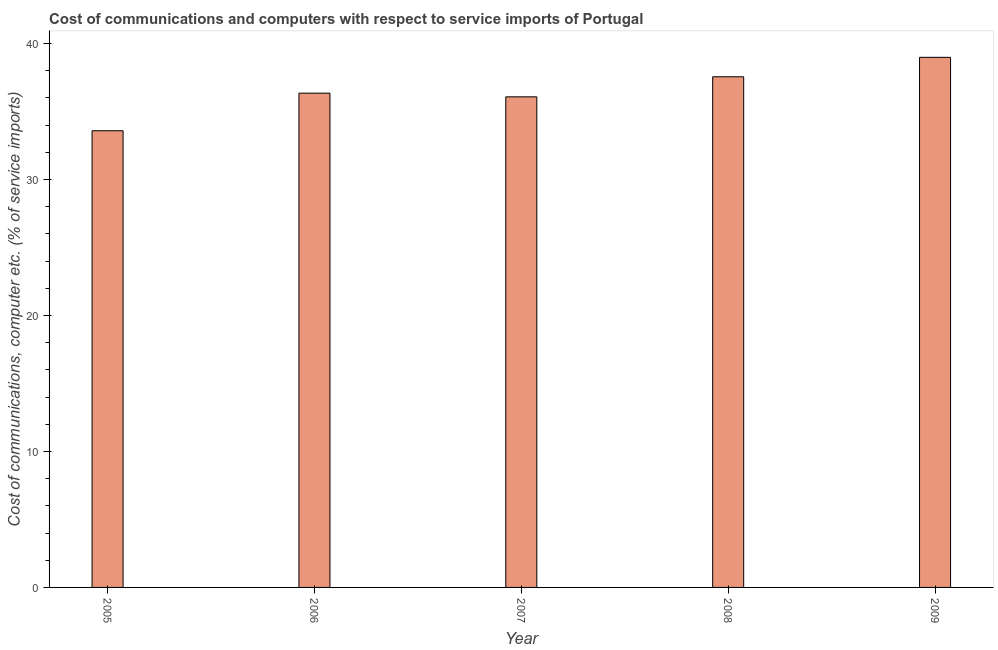Does the graph contain any zero values?
Your answer should be compact. No. What is the title of the graph?
Give a very brief answer. Cost of communications and computers with respect to service imports of Portugal. What is the label or title of the X-axis?
Your answer should be compact. Year. What is the label or title of the Y-axis?
Your answer should be very brief. Cost of communications, computer etc. (% of service imports). What is the cost of communications and computer in 2007?
Make the answer very short. 36.08. Across all years, what is the maximum cost of communications and computer?
Your answer should be compact. 38.99. Across all years, what is the minimum cost of communications and computer?
Make the answer very short. 33.59. In which year was the cost of communications and computer minimum?
Provide a succinct answer. 2005. What is the sum of the cost of communications and computer?
Offer a terse response. 182.57. What is the difference between the cost of communications and computer in 2007 and 2009?
Your answer should be very brief. -2.9. What is the average cost of communications and computer per year?
Your answer should be compact. 36.51. What is the median cost of communications and computer?
Make the answer very short. 36.35. In how many years, is the cost of communications and computer greater than 2 %?
Ensure brevity in your answer.  5. What is the ratio of the cost of communications and computer in 2005 to that in 2009?
Keep it short and to the point. 0.86. Is the difference between the cost of communications and computer in 2005 and 2006 greater than the difference between any two years?
Provide a succinct answer. No. What is the difference between the highest and the second highest cost of communications and computer?
Ensure brevity in your answer.  1.43. Is the sum of the cost of communications and computer in 2006 and 2009 greater than the maximum cost of communications and computer across all years?
Your answer should be very brief. Yes. What is the difference between the highest and the lowest cost of communications and computer?
Your response must be concise. 5.4. In how many years, is the cost of communications and computer greater than the average cost of communications and computer taken over all years?
Your answer should be very brief. 2. Are all the bars in the graph horizontal?
Ensure brevity in your answer.  No. How many years are there in the graph?
Offer a very short reply. 5. What is the Cost of communications, computer etc. (% of service imports) in 2005?
Provide a short and direct response. 33.59. What is the Cost of communications, computer etc. (% of service imports) in 2006?
Keep it short and to the point. 36.35. What is the Cost of communications, computer etc. (% of service imports) in 2007?
Your answer should be very brief. 36.08. What is the Cost of communications, computer etc. (% of service imports) in 2008?
Provide a short and direct response. 37.56. What is the Cost of communications, computer etc. (% of service imports) of 2009?
Offer a terse response. 38.99. What is the difference between the Cost of communications, computer etc. (% of service imports) in 2005 and 2006?
Keep it short and to the point. -2.77. What is the difference between the Cost of communications, computer etc. (% of service imports) in 2005 and 2007?
Ensure brevity in your answer.  -2.5. What is the difference between the Cost of communications, computer etc. (% of service imports) in 2005 and 2008?
Offer a very short reply. -3.97. What is the difference between the Cost of communications, computer etc. (% of service imports) in 2005 and 2009?
Provide a succinct answer. -5.4. What is the difference between the Cost of communications, computer etc. (% of service imports) in 2006 and 2007?
Offer a terse response. 0.27. What is the difference between the Cost of communications, computer etc. (% of service imports) in 2006 and 2008?
Offer a terse response. -1.21. What is the difference between the Cost of communications, computer etc. (% of service imports) in 2006 and 2009?
Give a very brief answer. -2.63. What is the difference between the Cost of communications, computer etc. (% of service imports) in 2007 and 2008?
Offer a terse response. -1.48. What is the difference between the Cost of communications, computer etc. (% of service imports) in 2007 and 2009?
Make the answer very short. -2.91. What is the difference between the Cost of communications, computer etc. (% of service imports) in 2008 and 2009?
Your response must be concise. -1.43. What is the ratio of the Cost of communications, computer etc. (% of service imports) in 2005 to that in 2006?
Your response must be concise. 0.92. What is the ratio of the Cost of communications, computer etc. (% of service imports) in 2005 to that in 2008?
Provide a short and direct response. 0.89. What is the ratio of the Cost of communications, computer etc. (% of service imports) in 2005 to that in 2009?
Ensure brevity in your answer.  0.86. What is the ratio of the Cost of communications, computer etc. (% of service imports) in 2006 to that in 2008?
Your response must be concise. 0.97. What is the ratio of the Cost of communications, computer etc. (% of service imports) in 2006 to that in 2009?
Provide a short and direct response. 0.93. What is the ratio of the Cost of communications, computer etc. (% of service imports) in 2007 to that in 2008?
Your answer should be compact. 0.96. What is the ratio of the Cost of communications, computer etc. (% of service imports) in 2007 to that in 2009?
Give a very brief answer. 0.93. 